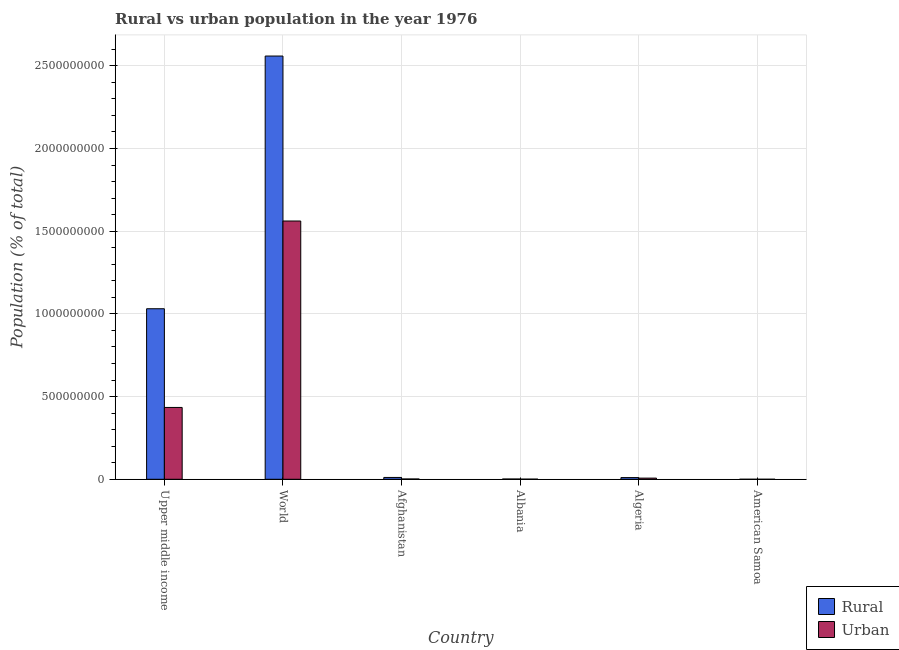How many different coloured bars are there?
Give a very brief answer. 2. How many groups of bars are there?
Keep it short and to the point. 6. Are the number of bars per tick equal to the number of legend labels?
Provide a succinct answer. Yes. What is the label of the 5th group of bars from the left?
Offer a very short reply. Algeria. What is the urban population density in Albania?
Your answer should be compact. 8.09e+05. Across all countries, what is the maximum rural population density?
Your answer should be very brief. 2.56e+09. Across all countries, what is the minimum urban population density?
Ensure brevity in your answer.  2.21e+04. In which country was the rural population density minimum?
Your response must be concise. American Samoa. What is the total urban population density in the graph?
Keep it short and to the point. 2.01e+09. What is the difference between the rural population density in Algeria and that in World?
Your answer should be very brief. -2.55e+09. What is the difference between the rural population density in American Samoa and the urban population density in World?
Your answer should be very brief. -1.56e+09. What is the average urban population density per country?
Offer a terse response. 3.34e+08. What is the difference between the urban population density and rural population density in World?
Your response must be concise. -9.98e+08. What is the ratio of the rural population density in Albania to that in World?
Provide a short and direct response. 0. Is the urban population density in Afghanistan less than that in Upper middle income?
Provide a succinct answer. Yes. Is the difference between the urban population density in Afghanistan and World greater than the difference between the rural population density in Afghanistan and World?
Ensure brevity in your answer.  Yes. What is the difference between the highest and the second highest urban population density?
Offer a very short reply. 1.13e+09. What is the difference between the highest and the lowest urban population density?
Offer a terse response. 1.56e+09. In how many countries, is the rural population density greater than the average rural population density taken over all countries?
Make the answer very short. 2. Is the sum of the urban population density in Afghanistan and Upper middle income greater than the maximum rural population density across all countries?
Your answer should be very brief. No. What does the 2nd bar from the left in Algeria represents?
Provide a short and direct response. Urban. What does the 2nd bar from the right in World represents?
Offer a terse response. Rural. How many bars are there?
Ensure brevity in your answer.  12. What is the difference between two consecutive major ticks on the Y-axis?
Keep it short and to the point. 5.00e+08. Does the graph contain any zero values?
Offer a terse response. No. Does the graph contain grids?
Make the answer very short. Yes. How many legend labels are there?
Keep it short and to the point. 2. How are the legend labels stacked?
Your response must be concise. Vertical. What is the title of the graph?
Your response must be concise. Rural vs urban population in the year 1976. Does "Girls" appear as one of the legend labels in the graph?
Keep it short and to the point. No. What is the label or title of the X-axis?
Provide a short and direct response. Country. What is the label or title of the Y-axis?
Offer a very short reply. Population (% of total). What is the Population (% of total) of Rural in Upper middle income?
Provide a succinct answer. 1.03e+09. What is the Population (% of total) in Urban in Upper middle income?
Offer a very short reply. 4.34e+08. What is the Population (% of total) in Rural in World?
Offer a very short reply. 2.56e+09. What is the Population (% of total) of Urban in World?
Keep it short and to the point. 1.56e+09. What is the Population (% of total) in Rural in Afghanistan?
Your answer should be very brief. 1.10e+07. What is the Population (% of total) in Urban in Afghanistan?
Offer a terse response. 1.80e+06. What is the Population (% of total) in Rural in Albania?
Provide a short and direct response. 1.65e+06. What is the Population (% of total) of Urban in Albania?
Provide a succinct answer. 8.09e+05. What is the Population (% of total) of Rural in Algeria?
Offer a very short reply. 1.02e+07. What is the Population (% of total) in Urban in Algeria?
Make the answer very short. 6.96e+06. What is the Population (% of total) in Rural in American Samoa?
Give a very brief answer. 8267. What is the Population (% of total) of Urban in American Samoa?
Your response must be concise. 2.21e+04. Across all countries, what is the maximum Population (% of total) of Rural?
Give a very brief answer. 2.56e+09. Across all countries, what is the maximum Population (% of total) of Urban?
Keep it short and to the point. 1.56e+09. Across all countries, what is the minimum Population (% of total) in Rural?
Make the answer very short. 8267. Across all countries, what is the minimum Population (% of total) in Urban?
Keep it short and to the point. 2.21e+04. What is the total Population (% of total) in Rural in the graph?
Your response must be concise. 3.61e+09. What is the total Population (% of total) of Urban in the graph?
Offer a terse response. 2.01e+09. What is the difference between the Population (% of total) in Rural in Upper middle income and that in World?
Your answer should be compact. -1.53e+09. What is the difference between the Population (% of total) of Urban in Upper middle income and that in World?
Provide a short and direct response. -1.13e+09. What is the difference between the Population (% of total) of Rural in Upper middle income and that in Afghanistan?
Make the answer very short. 1.02e+09. What is the difference between the Population (% of total) of Urban in Upper middle income and that in Afghanistan?
Your answer should be compact. 4.33e+08. What is the difference between the Population (% of total) of Rural in Upper middle income and that in Albania?
Provide a short and direct response. 1.03e+09. What is the difference between the Population (% of total) of Urban in Upper middle income and that in Albania?
Your answer should be very brief. 4.34e+08. What is the difference between the Population (% of total) of Rural in Upper middle income and that in Algeria?
Your answer should be compact. 1.02e+09. What is the difference between the Population (% of total) of Urban in Upper middle income and that in Algeria?
Offer a very short reply. 4.27e+08. What is the difference between the Population (% of total) in Rural in Upper middle income and that in American Samoa?
Provide a succinct answer. 1.03e+09. What is the difference between the Population (% of total) of Urban in Upper middle income and that in American Samoa?
Provide a succinct answer. 4.34e+08. What is the difference between the Population (% of total) in Rural in World and that in Afghanistan?
Offer a very short reply. 2.55e+09. What is the difference between the Population (% of total) in Urban in World and that in Afghanistan?
Ensure brevity in your answer.  1.56e+09. What is the difference between the Population (% of total) in Rural in World and that in Albania?
Your answer should be very brief. 2.56e+09. What is the difference between the Population (% of total) in Urban in World and that in Albania?
Make the answer very short. 1.56e+09. What is the difference between the Population (% of total) of Rural in World and that in Algeria?
Provide a short and direct response. 2.55e+09. What is the difference between the Population (% of total) in Urban in World and that in Algeria?
Your response must be concise. 1.55e+09. What is the difference between the Population (% of total) in Rural in World and that in American Samoa?
Provide a short and direct response. 2.56e+09. What is the difference between the Population (% of total) of Urban in World and that in American Samoa?
Your answer should be compact. 1.56e+09. What is the difference between the Population (% of total) of Rural in Afghanistan and that in Albania?
Your answer should be very brief. 9.38e+06. What is the difference between the Population (% of total) in Urban in Afghanistan and that in Albania?
Your response must be concise. 9.91e+05. What is the difference between the Population (% of total) in Rural in Afghanistan and that in Algeria?
Ensure brevity in your answer.  8.03e+05. What is the difference between the Population (% of total) of Urban in Afghanistan and that in Algeria?
Give a very brief answer. -5.16e+06. What is the difference between the Population (% of total) of Rural in Afghanistan and that in American Samoa?
Your answer should be compact. 1.10e+07. What is the difference between the Population (% of total) in Urban in Afghanistan and that in American Samoa?
Ensure brevity in your answer.  1.78e+06. What is the difference between the Population (% of total) of Rural in Albania and that in Algeria?
Your answer should be very brief. -8.58e+06. What is the difference between the Population (% of total) of Urban in Albania and that in Algeria?
Make the answer very short. -6.15e+06. What is the difference between the Population (% of total) in Rural in Albania and that in American Samoa?
Offer a terse response. 1.64e+06. What is the difference between the Population (% of total) in Urban in Albania and that in American Samoa?
Ensure brevity in your answer.  7.87e+05. What is the difference between the Population (% of total) of Rural in Algeria and that in American Samoa?
Your answer should be compact. 1.02e+07. What is the difference between the Population (% of total) in Urban in Algeria and that in American Samoa?
Ensure brevity in your answer.  6.94e+06. What is the difference between the Population (% of total) of Rural in Upper middle income and the Population (% of total) of Urban in World?
Keep it short and to the point. -5.30e+08. What is the difference between the Population (% of total) of Rural in Upper middle income and the Population (% of total) of Urban in Afghanistan?
Provide a short and direct response. 1.03e+09. What is the difference between the Population (% of total) of Rural in Upper middle income and the Population (% of total) of Urban in Albania?
Your answer should be compact. 1.03e+09. What is the difference between the Population (% of total) of Rural in Upper middle income and the Population (% of total) of Urban in Algeria?
Make the answer very short. 1.02e+09. What is the difference between the Population (% of total) of Rural in Upper middle income and the Population (% of total) of Urban in American Samoa?
Your answer should be compact. 1.03e+09. What is the difference between the Population (% of total) in Rural in World and the Population (% of total) in Urban in Afghanistan?
Offer a very short reply. 2.56e+09. What is the difference between the Population (% of total) in Rural in World and the Population (% of total) in Urban in Albania?
Give a very brief answer. 2.56e+09. What is the difference between the Population (% of total) in Rural in World and the Population (% of total) in Urban in Algeria?
Give a very brief answer. 2.55e+09. What is the difference between the Population (% of total) in Rural in World and the Population (% of total) in Urban in American Samoa?
Your answer should be compact. 2.56e+09. What is the difference between the Population (% of total) in Rural in Afghanistan and the Population (% of total) in Urban in Albania?
Ensure brevity in your answer.  1.02e+07. What is the difference between the Population (% of total) in Rural in Afghanistan and the Population (% of total) in Urban in Algeria?
Keep it short and to the point. 4.07e+06. What is the difference between the Population (% of total) of Rural in Afghanistan and the Population (% of total) of Urban in American Samoa?
Offer a very short reply. 1.10e+07. What is the difference between the Population (% of total) in Rural in Albania and the Population (% of total) in Urban in Algeria?
Make the answer very short. -5.31e+06. What is the difference between the Population (% of total) in Rural in Albania and the Population (% of total) in Urban in American Samoa?
Your response must be concise. 1.63e+06. What is the difference between the Population (% of total) in Rural in Algeria and the Population (% of total) in Urban in American Samoa?
Make the answer very short. 1.02e+07. What is the average Population (% of total) in Rural per country?
Provide a succinct answer. 6.02e+08. What is the average Population (% of total) in Urban per country?
Make the answer very short. 3.34e+08. What is the difference between the Population (% of total) of Rural and Population (% of total) of Urban in Upper middle income?
Make the answer very short. 5.97e+08. What is the difference between the Population (% of total) in Rural and Population (% of total) in Urban in World?
Your answer should be compact. 9.98e+08. What is the difference between the Population (% of total) in Rural and Population (% of total) in Urban in Afghanistan?
Your answer should be compact. 9.23e+06. What is the difference between the Population (% of total) of Rural and Population (% of total) of Urban in Albania?
Ensure brevity in your answer.  8.40e+05. What is the difference between the Population (% of total) in Rural and Population (% of total) in Urban in Algeria?
Offer a very short reply. 3.27e+06. What is the difference between the Population (% of total) of Rural and Population (% of total) of Urban in American Samoa?
Make the answer very short. -1.38e+04. What is the ratio of the Population (% of total) in Rural in Upper middle income to that in World?
Provide a succinct answer. 0.4. What is the ratio of the Population (% of total) of Urban in Upper middle income to that in World?
Ensure brevity in your answer.  0.28. What is the ratio of the Population (% of total) in Rural in Upper middle income to that in Afghanistan?
Ensure brevity in your answer.  93.48. What is the ratio of the Population (% of total) in Urban in Upper middle income to that in Afghanistan?
Ensure brevity in your answer.  241.28. What is the ratio of the Population (% of total) of Rural in Upper middle income to that in Albania?
Your response must be concise. 625.15. What is the ratio of the Population (% of total) in Urban in Upper middle income to that in Albania?
Your answer should be compact. 536.85. What is the ratio of the Population (% of total) in Rural in Upper middle income to that in Algeria?
Ensure brevity in your answer.  100.81. What is the ratio of the Population (% of total) in Urban in Upper middle income to that in Algeria?
Keep it short and to the point. 62.39. What is the ratio of the Population (% of total) in Rural in Upper middle income to that in American Samoa?
Offer a terse response. 1.25e+05. What is the ratio of the Population (% of total) in Urban in Upper middle income to that in American Samoa?
Your answer should be compact. 1.97e+04. What is the ratio of the Population (% of total) of Rural in World to that in Afghanistan?
Ensure brevity in your answer.  231.99. What is the ratio of the Population (% of total) of Urban in World to that in Afghanistan?
Ensure brevity in your answer.  867.52. What is the ratio of the Population (% of total) of Rural in World to that in Albania?
Keep it short and to the point. 1551.5. What is the ratio of the Population (% of total) in Urban in World to that in Albania?
Keep it short and to the point. 1930.21. What is the ratio of the Population (% of total) of Rural in World to that in Algeria?
Your answer should be compact. 250.19. What is the ratio of the Population (% of total) in Urban in World to that in Algeria?
Your answer should be very brief. 224.32. What is the ratio of the Population (% of total) of Rural in World to that in American Samoa?
Offer a very short reply. 3.10e+05. What is the ratio of the Population (% of total) of Urban in World to that in American Samoa?
Provide a succinct answer. 7.08e+04. What is the ratio of the Population (% of total) in Rural in Afghanistan to that in Albania?
Provide a short and direct response. 6.69. What is the ratio of the Population (% of total) in Urban in Afghanistan to that in Albania?
Your answer should be compact. 2.23. What is the ratio of the Population (% of total) of Rural in Afghanistan to that in Algeria?
Provide a succinct answer. 1.08. What is the ratio of the Population (% of total) of Urban in Afghanistan to that in Algeria?
Your response must be concise. 0.26. What is the ratio of the Population (% of total) of Rural in Afghanistan to that in American Samoa?
Your response must be concise. 1334.37. What is the ratio of the Population (% of total) of Urban in Afghanistan to that in American Samoa?
Your answer should be compact. 81.61. What is the ratio of the Population (% of total) of Rural in Albania to that in Algeria?
Offer a very short reply. 0.16. What is the ratio of the Population (% of total) in Urban in Albania to that in Algeria?
Give a very brief answer. 0.12. What is the ratio of the Population (% of total) in Rural in Albania to that in American Samoa?
Your answer should be compact. 199.53. What is the ratio of the Population (% of total) in Urban in Albania to that in American Samoa?
Ensure brevity in your answer.  36.68. What is the ratio of the Population (% of total) in Rural in Algeria to that in American Samoa?
Your answer should be compact. 1237.29. What is the ratio of the Population (% of total) in Urban in Algeria to that in American Samoa?
Give a very brief answer. 315.6. What is the difference between the highest and the second highest Population (% of total) of Rural?
Give a very brief answer. 1.53e+09. What is the difference between the highest and the second highest Population (% of total) of Urban?
Provide a succinct answer. 1.13e+09. What is the difference between the highest and the lowest Population (% of total) in Rural?
Provide a succinct answer. 2.56e+09. What is the difference between the highest and the lowest Population (% of total) of Urban?
Make the answer very short. 1.56e+09. 